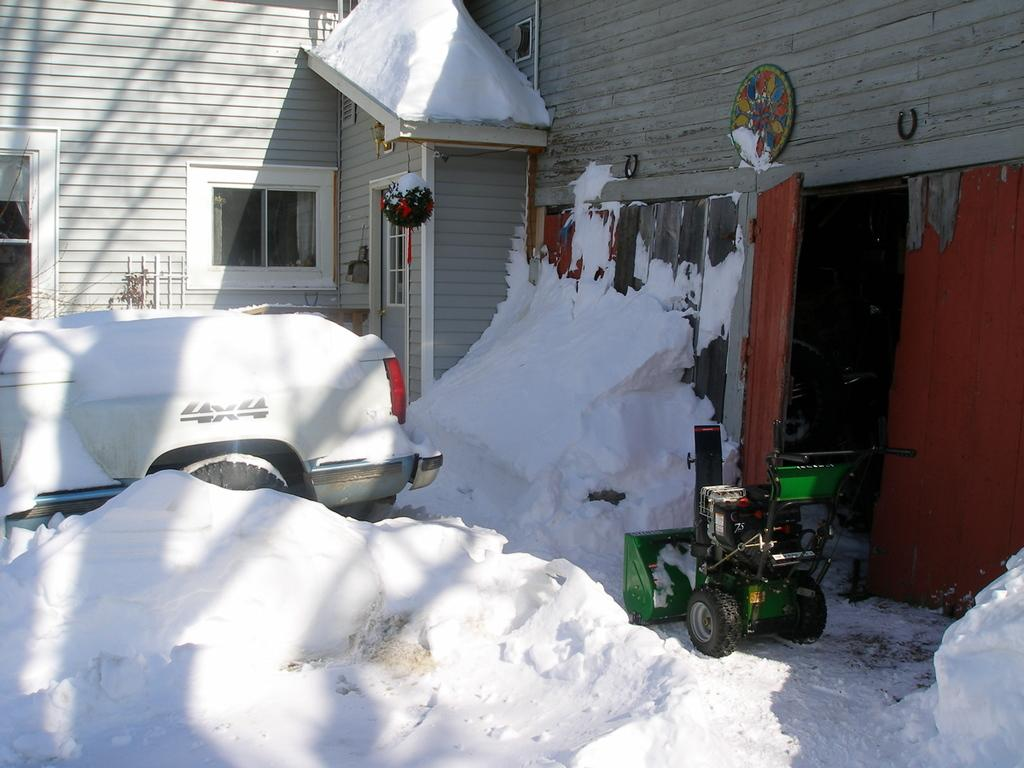What is the weather like in the image? There is snow in the image, indicating a cold and likely wintery environment. What type of vehicle is present in the image? There is a vehicle in the image, but its specific type is not mentioned in the facts. What is the purpose of the smoke machine in the image? The purpose of the smoke machine in the image is not mentioned in the facts. What can be seen in the background of the image? There is a wooden house in the background of the image. What color is the dress worn by the person in the middle of the image? There is no person or dress present in the image; it features snow, a vehicle, a smoke machine, and a wooden house in the background. 